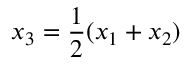<formula> <loc_0><loc_0><loc_500><loc_500>x _ { 3 } = { \frac { 1 } { 2 } } ( x _ { 1 } + x _ { 2 } )</formula> 